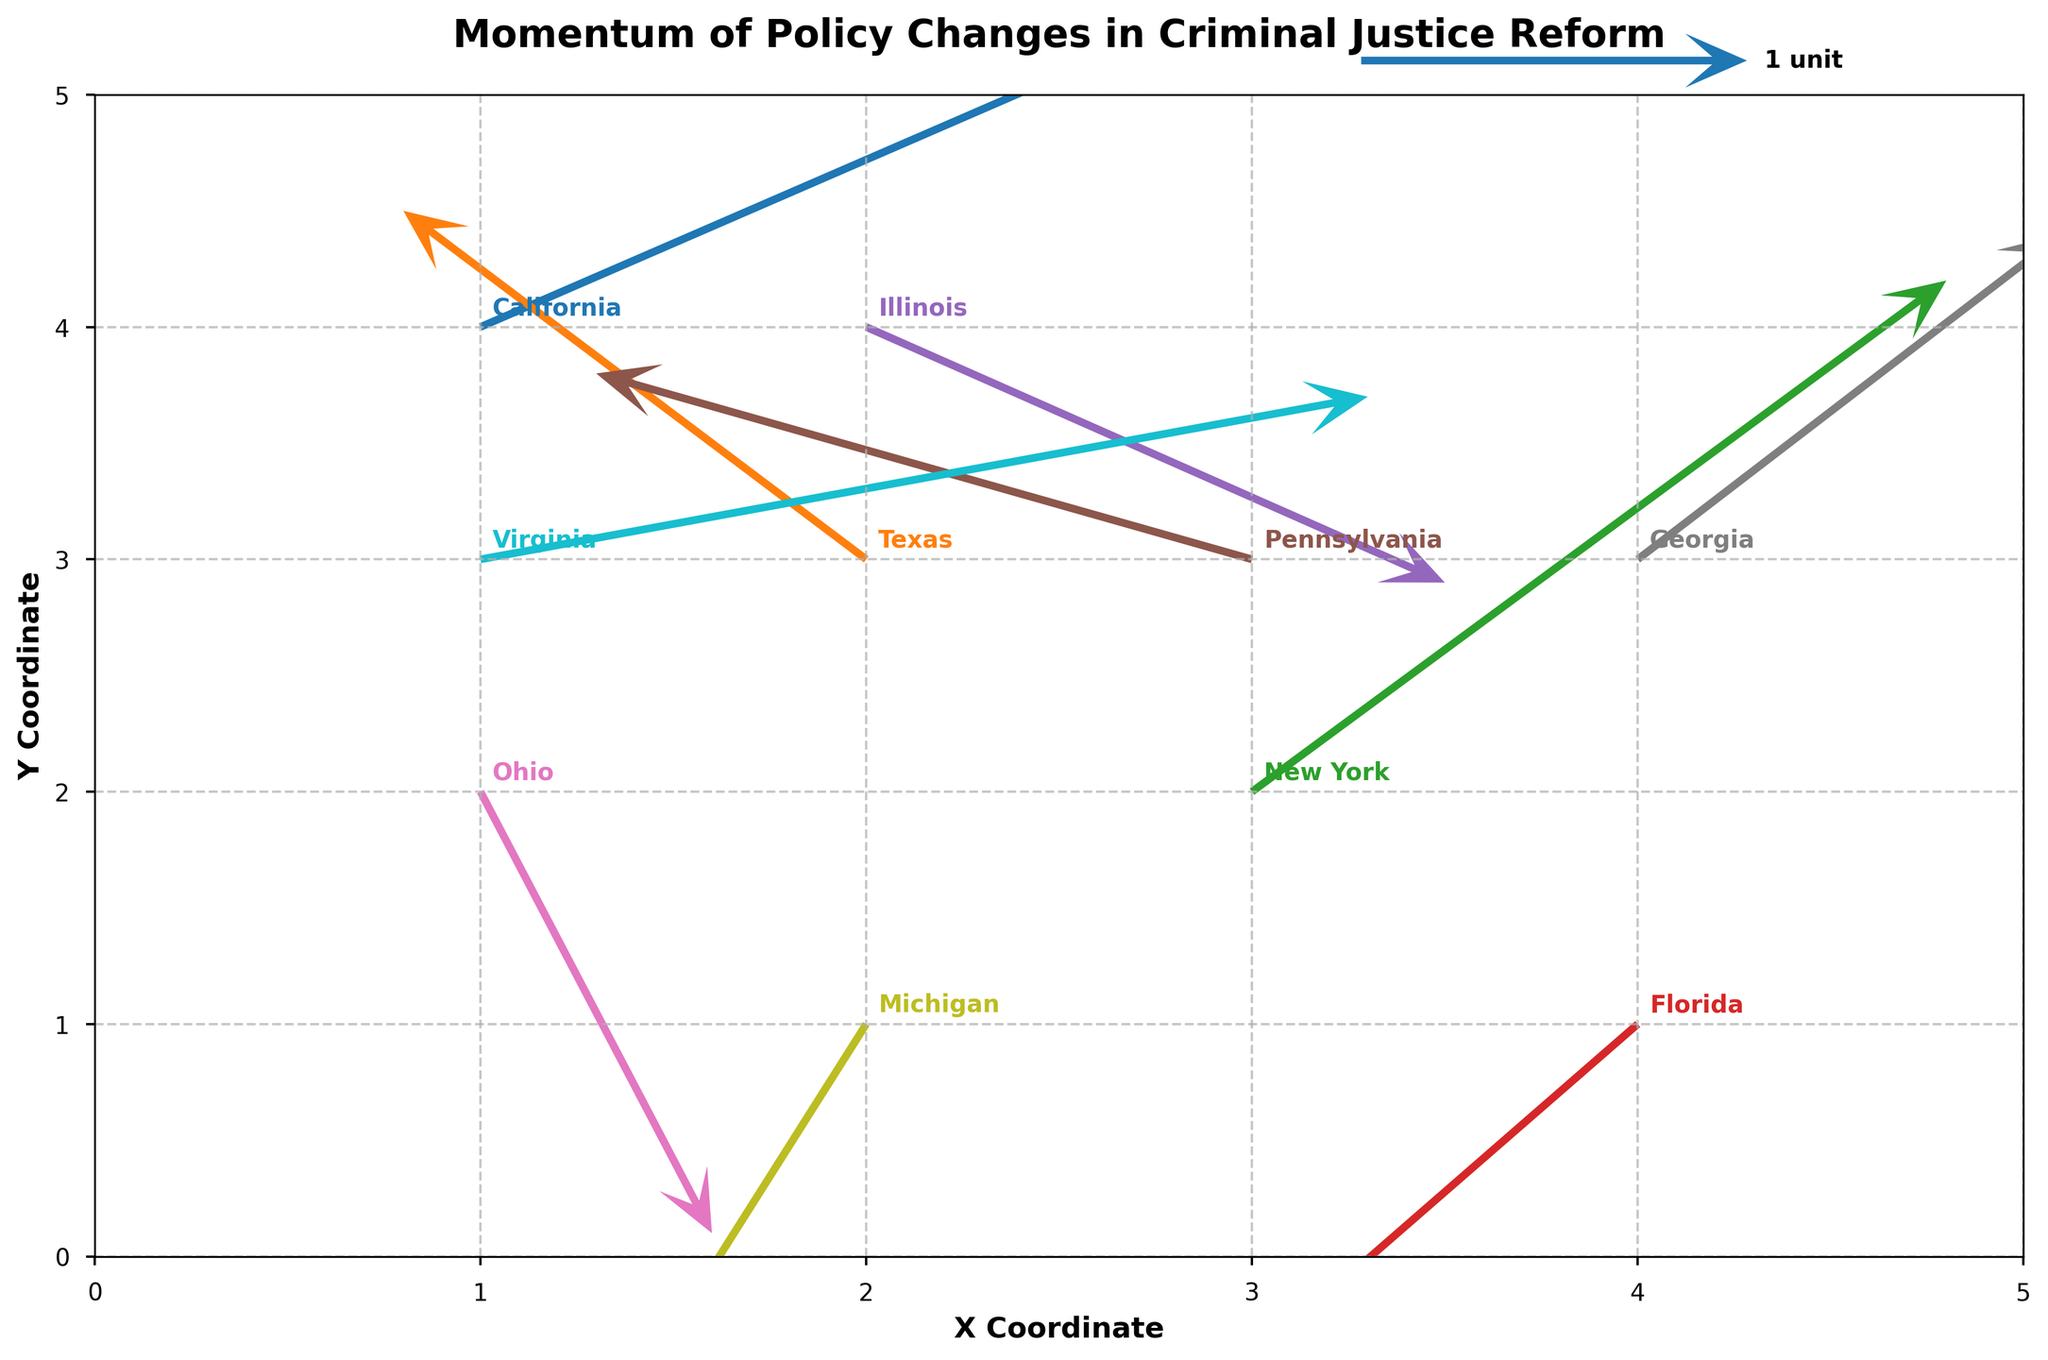what is the title of the plot? The title of the plot is usually displayed at the top part of the figure. In this case, the title is "Momentum of Policy Changes in Criminal Justice Reform".
Answer: Momentum of Policy Changes in Criminal Justice Reform what does the x-axis represent? The label for the x-axis can be seen directly on the plot. Here it is labeled as "X Coordinate".
Answer: X Coordinate which state has the most positive horizontal movement? By comparing the horizontal arrow lengths (U values), California has the most positive horizontal movement (U = 2.5).
Answer: California which states have negative vertical movements? By looking at the directions of the arrows, Texas, Florida, Illinois, Ohio, and Michigan all have downward arrows, indicating negative vertical movements (negative V values).
Answer: Texas, Florida, Illinois, Ohio, Michigan which state has moved downwards and to the right? Looking for negative V values and positive U values, Illinois (U = 1.5, V = -1.1) and Ohio (U = 0.6, V = -1.9) have downward and rightward movements.
Answer: Illinois, Ohio how many states have an upward movement? Observing the direction of the arrows pointing upwards (positive V values), California, Texas, New York, Pennsylvania, Georgia, and Virginia have upward movements. Six states in total have upward movement.
Answer: 6 how can we distinguish between states in the plot? States are distinguished by the position of their coordinates (X, Y) and the direction of the arrows (U, V). Additionally, each state is labeled near its arrow in bold, unique colors.
Answer: By coordinates, arrow direction, and color labels which state has the greatest overall movement? The overall movement can be calculated using the Pythagorean Theorem on the vectors' components (U, V). We calculate:  
California: sqrt(2.5^2 + 1.8^2) = 3.06  
Texas: sqrt(-1.2^2 + 1.5^2) = 1.92  
New York: sqrt(1.8^2 + 2.2^2) = 2.86  
Florida: sqrt(-0.9^2 + -1.3^2) = 1.60  
Illinois: sqrt(1.5^2 + -1.1^2) = 1.87  
Pennsylvania: sqrt(-1.7^2 + 0.8^2) = 1.89  
Ohio: sqrt(0.6^2 + -1.9^2) = 1.98  
Georgia: sqrt(1.1^2 + 1.4^2) = 1.79  
Michigan: sqrt(-0.8^2 + -2.1^2) = 2.25  
Virginia: sqrt(2.3^2 + 0.7^2) = 2.39  
Comparing these, California has the greatest overall movement.
Answer: California which state has the closest policy change momentum to an equal horizontal and vertical movement? This can be interpreted as finding the state with U and V values that are closest in magnitude. First, calculate and compare the absolute differences:  
California: abs(2.5 - 1.8) = 0.7  
Texas: abs(-1.2 - 1.5) = 2.7  
New York: abs(1.8 - 2.2) = 0.4  
Florida: abs(-0.9 - -1.3) = 0.4  
Illinois: abs(1.5 - -1.1) = 2.6  
Pennsylvania: abs(-1.7 - 0.8) = 2.5  
Ohio: abs(0.6 - -1.9) = 2.5  
Georgia: abs(1.1 - 1.4) = 0.3  
Michigan: abs(-0.8 - -2.1) = 1.3  
Virginia: abs(2.3 - 0.7) = 1.6  
Georgia has the smallest difference, making it the close to having equal horizontal and vertical movement.
Answer: Georgia 